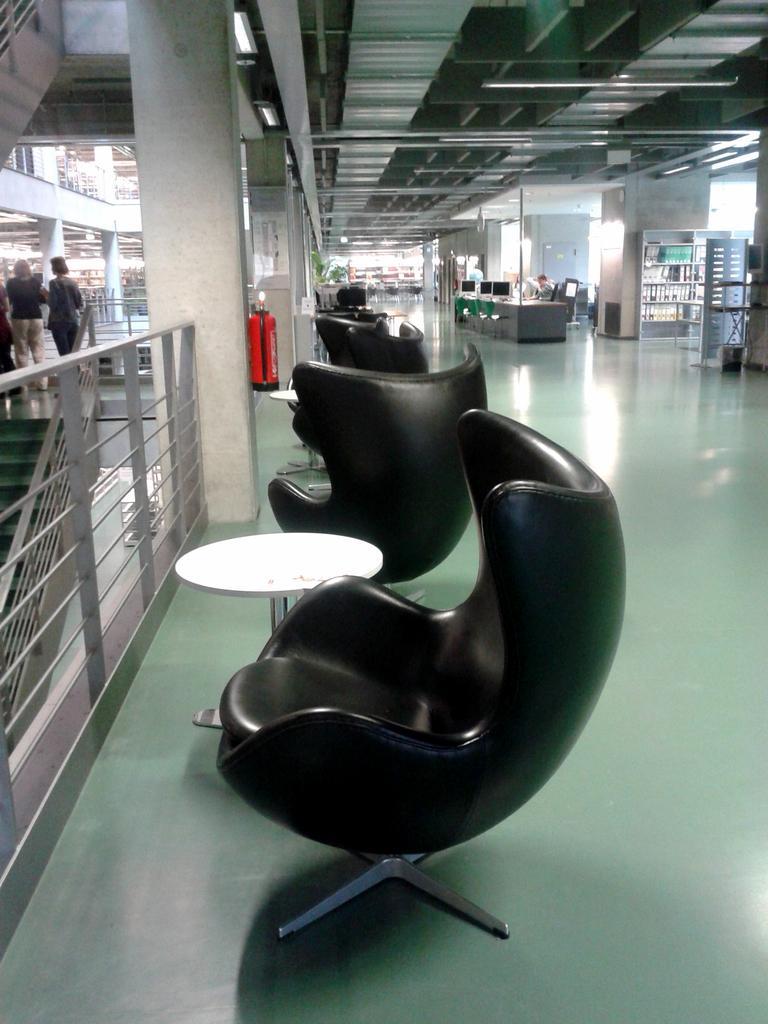Please provide a concise description of this image. In the middle of the image, there are three chairs black in color and a table of white in color is kept. In the left side of the image, there are two person standing. In the right middle of the image, there is a table, in front of which a person is sitting on the chair. Next to that a cupboard is there, in which bottles are kept. This image is taken inside a mall during day time. 